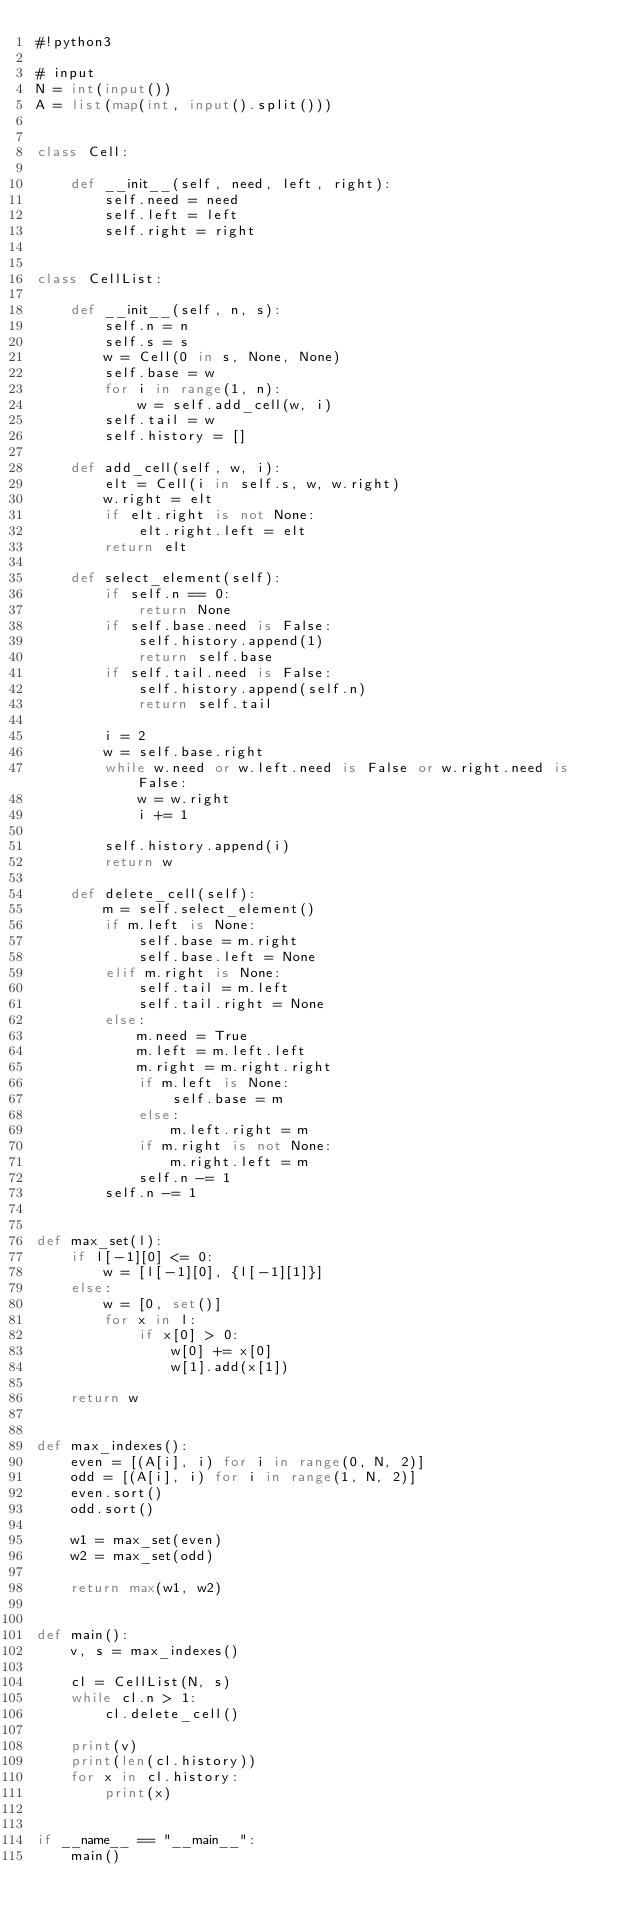Convert code to text. <code><loc_0><loc_0><loc_500><loc_500><_Python_>#!python3

# input
N = int(input())
A = list(map(int, input().split()))


class Cell:

    def __init__(self, need, left, right):
        self.need = need
        self.left = left
        self.right = right
    

class CellList:

    def __init__(self, n, s):
        self.n = n
        self.s = s
        w = Cell(0 in s, None, None)
        self.base = w
        for i in range(1, n):
            w = self.add_cell(w, i)
        self.tail = w
        self.history = []
    
    def add_cell(self, w, i):
        elt = Cell(i in self.s, w, w.right)
        w.right = elt
        if elt.right is not None:
            elt.right.left = elt
        return elt

    def select_element(self):
        if self.n == 0:
            return None
        if self.base.need is False:
            self.history.append(1)
            return self.base
        if self.tail.need is False:
            self.history.append(self.n)
            return self.tail
        
        i = 2
        w = self.base.right
        while w.need or w.left.need is False or w.right.need is False:
            w = w.right
            i += 1

        self.history.append(i)
        return w

    def delete_cell(self):
        m = self.select_element()
        if m.left is None:
            self.base = m.right
            self.base.left = None
        elif m.right is None:
            self.tail = m.left
            self.tail.right = None
        else:
            m.need = True
            m.left = m.left.left
            m.right = m.right.right
            if m.left is None:
                self.base = m
            else:
                m.left.right = m
            if m.right is not None:
                m.right.left = m
            self.n -= 1
        self.n -= 1


def max_set(l):
    if l[-1][0] <= 0:
        w = [l[-1][0], {l[-1][1]}]
    else:
        w = [0, set()]
        for x in l:
            if x[0] > 0:
                w[0] += x[0]
                w[1].add(x[1])
    
    return w


def max_indexes():
    even = [(A[i], i) for i in range(0, N, 2)]
    odd = [(A[i], i) for i in range(1, N, 2)]
    even.sort()
    odd.sort()

    w1 = max_set(even)
    w2 = max_set(odd)

    return max(w1, w2)
        
    
def main():
    v, s = max_indexes()
    
    cl = CellList(N, s)
    while cl.n > 1:
        cl.delete_cell()
        
    print(v)
    print(len(cl.history))
    for x in cl.history:
        print(x)


if __name__ == "__main__":
    main()
</code> 